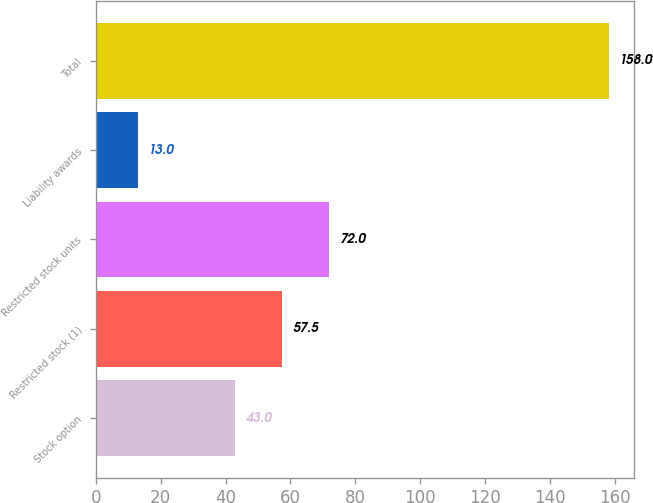Convert chart to OTSL. <chart><loc_0><loc_0><loc_500><loc_500><bar_chart><fcel>Stock option<fcel>Restricted stock (1)<fcel>Restricted stock units<fcel>Liability awards<fcel>Total<nl><fcel>43<fcel>57.5<fcel>72<fcel>13<fcel>158<nl></chart> 